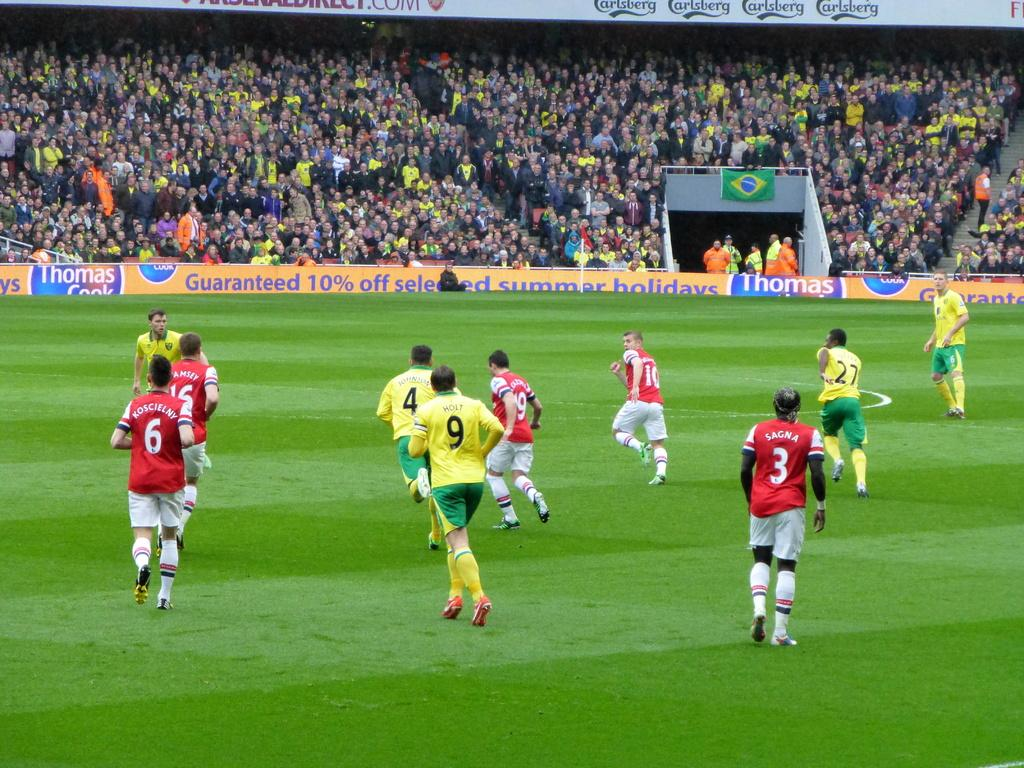Provide a one-sentence caption for the provided image. Soccer player are running on a filed and number 9 is wearing a yellow jersey. 